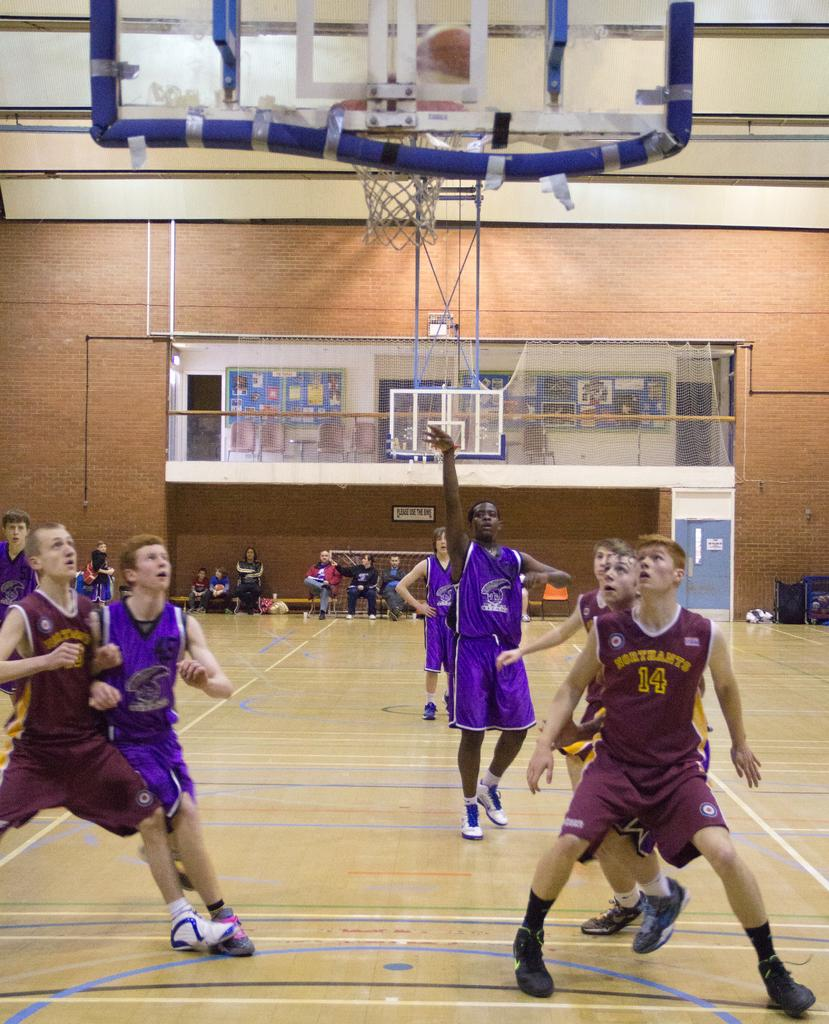<image>
Give a short and clear explanation of the subsequent image. a player has the number 14 on their jersey 